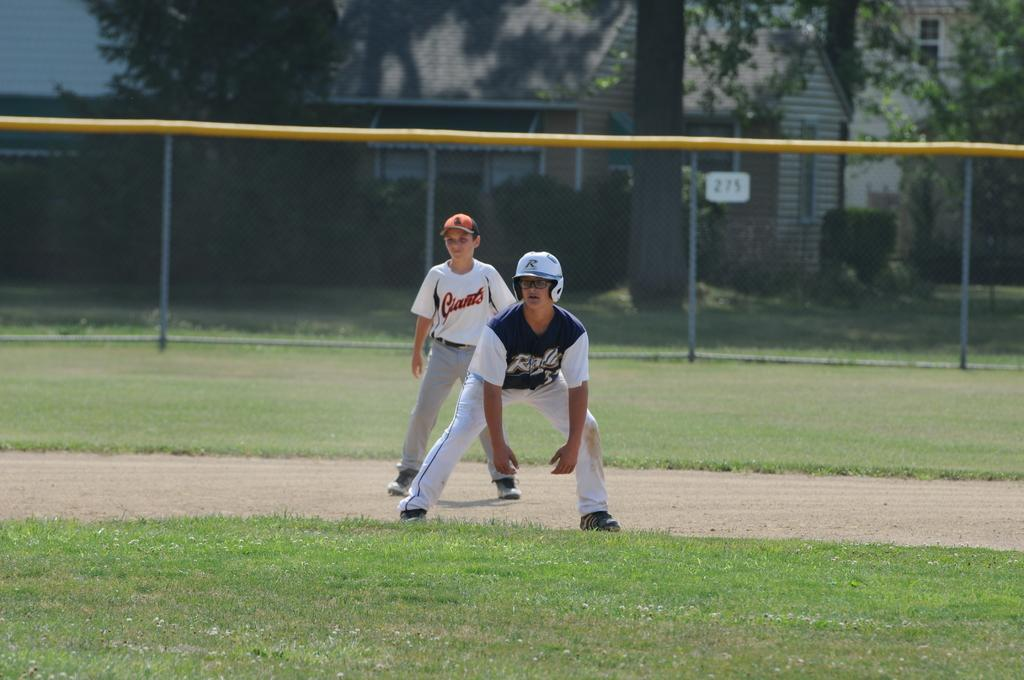<image>
Share a concise interpretation of the image provided. A baseball player in a white and red Giants baseball jersey. 